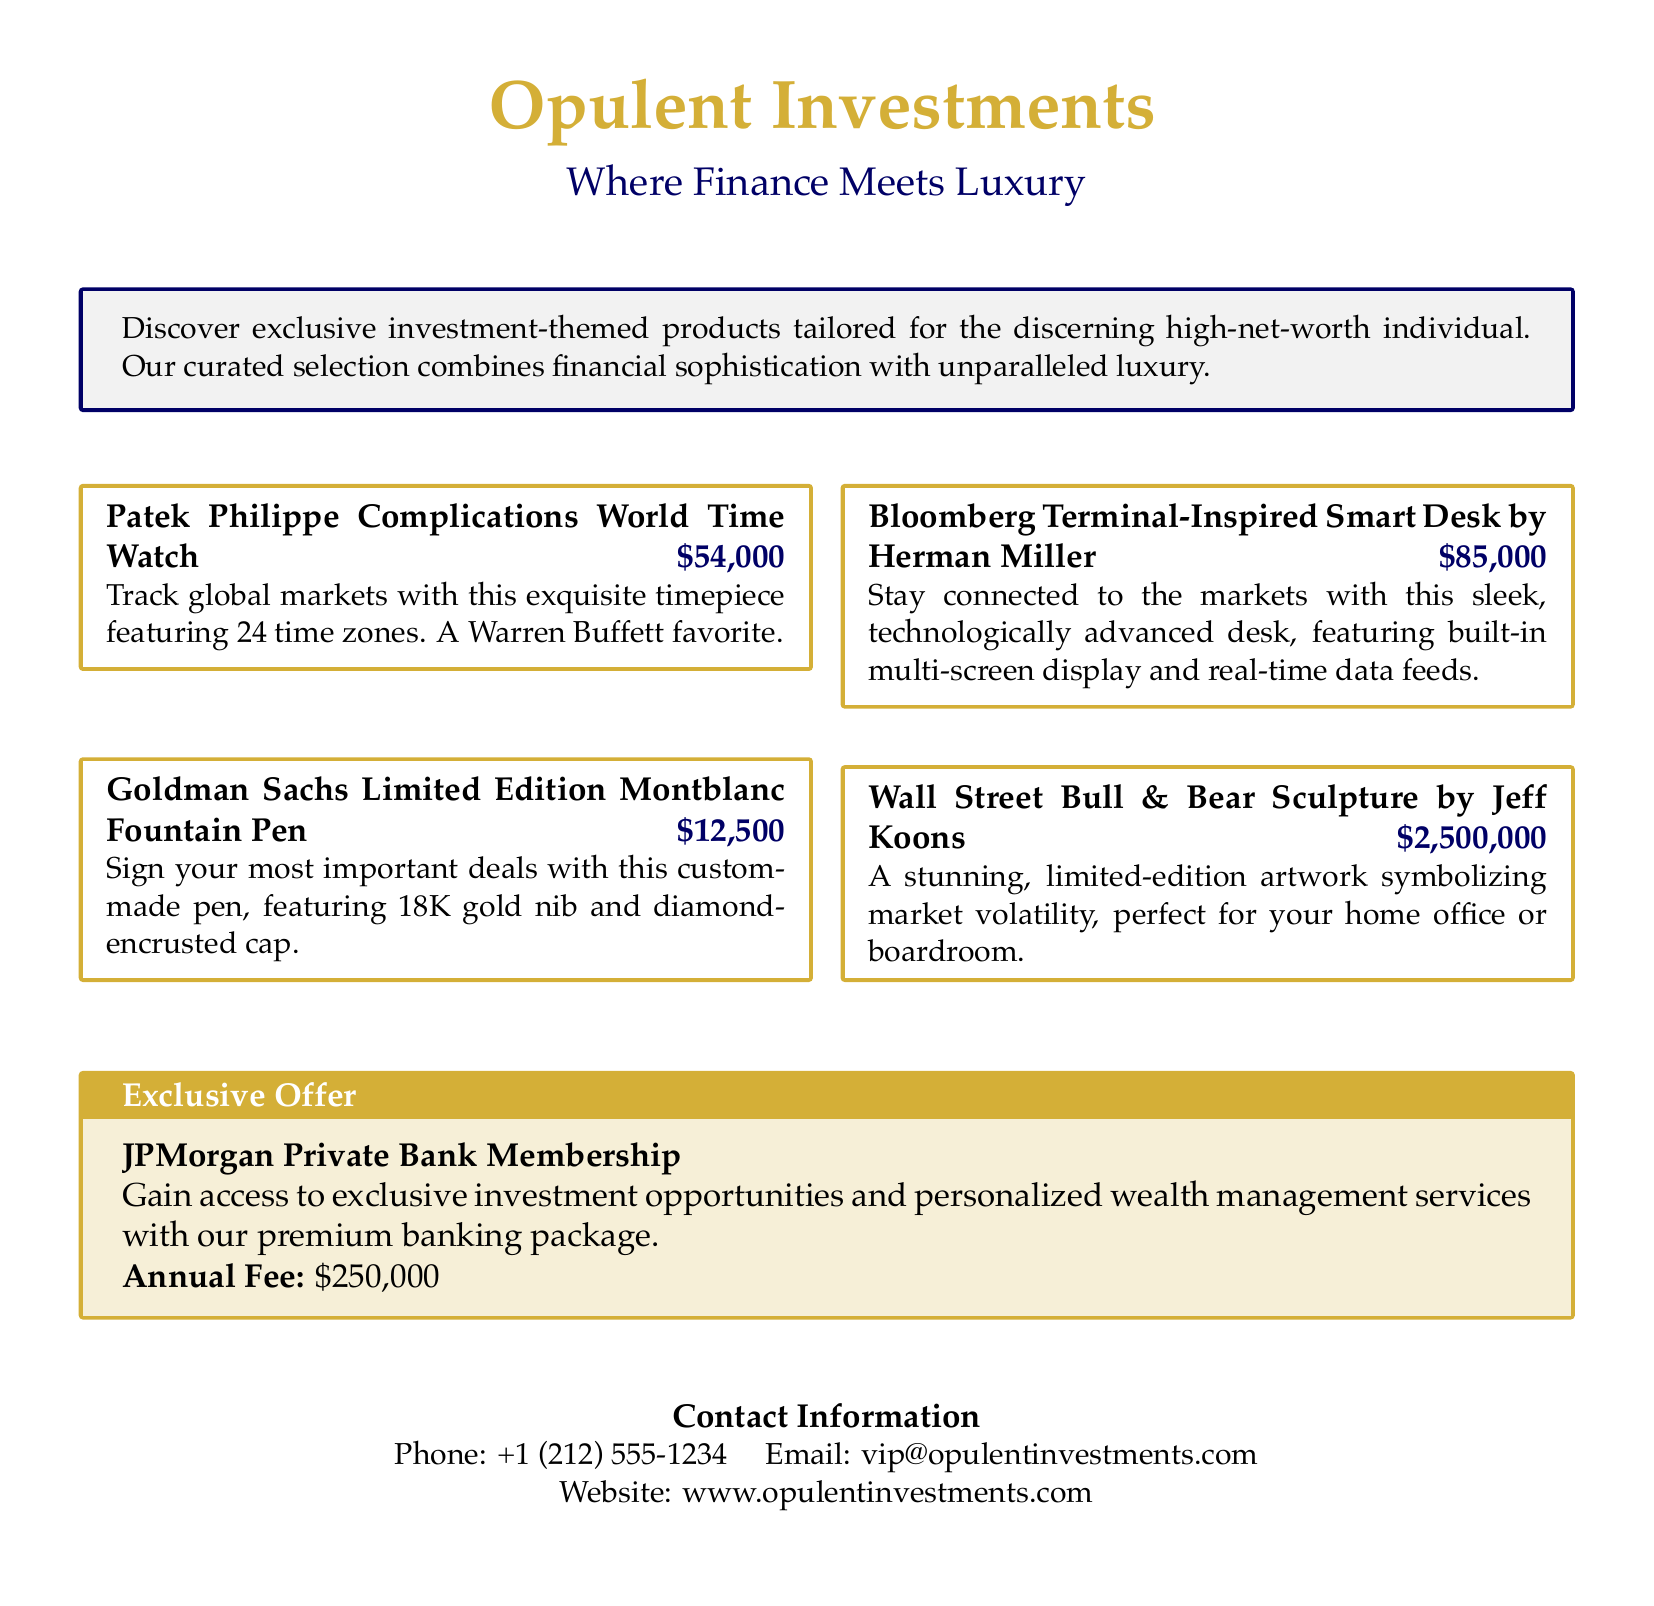What is the title of the catalog? The title is prominently displayed at the top of the document.
Answer: Opulent Investments What is the color of the text used for the tagline? The color of the tagline text is specified in the document.
Answer: Dark Blue How much does the Patek Philippe Complications World Time Watch cost? The cost is listed next to the product description.
Answer: $54,000 What is included in the JPMorgan Private Bank Membership? The document describes the benefits of this membership clearly.
Answer: Access to exclusive investment opportunities Who is the artist of the Wall Street Bull & Bear Sculpture? The document attributes the sculpture to a well-known artist.
Answer: Jeff Koons What is the annual fee for the JPMorgan Private Bank Membership? This fee is stated directly under the membership description.
Answer: $250,000 What type of product is the Bloomberg Terminal-Inspired Smart Desk? The product category can be inferred from its description in the document.
Answer: Desk Which product is described as a Warren Buffett favorite? The document emphasizes this connection with the watch.
Answer: Patek Philippe Complications World Time Watch 